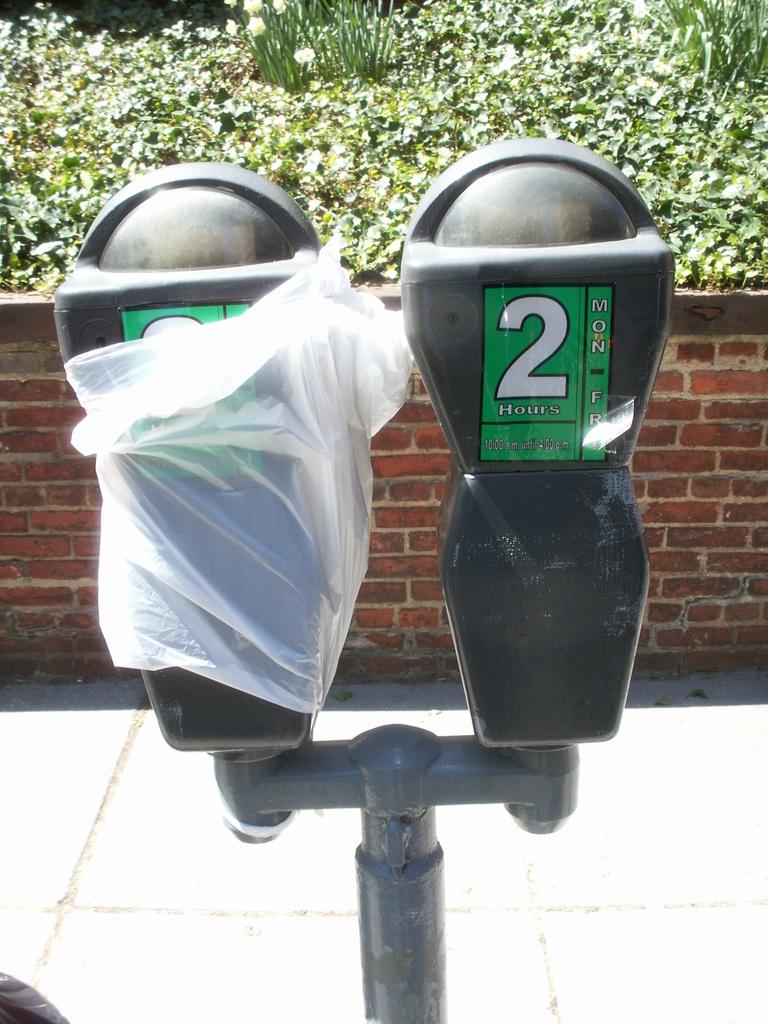How long can you use this meter?
Offer a terse response. 2 hours. 